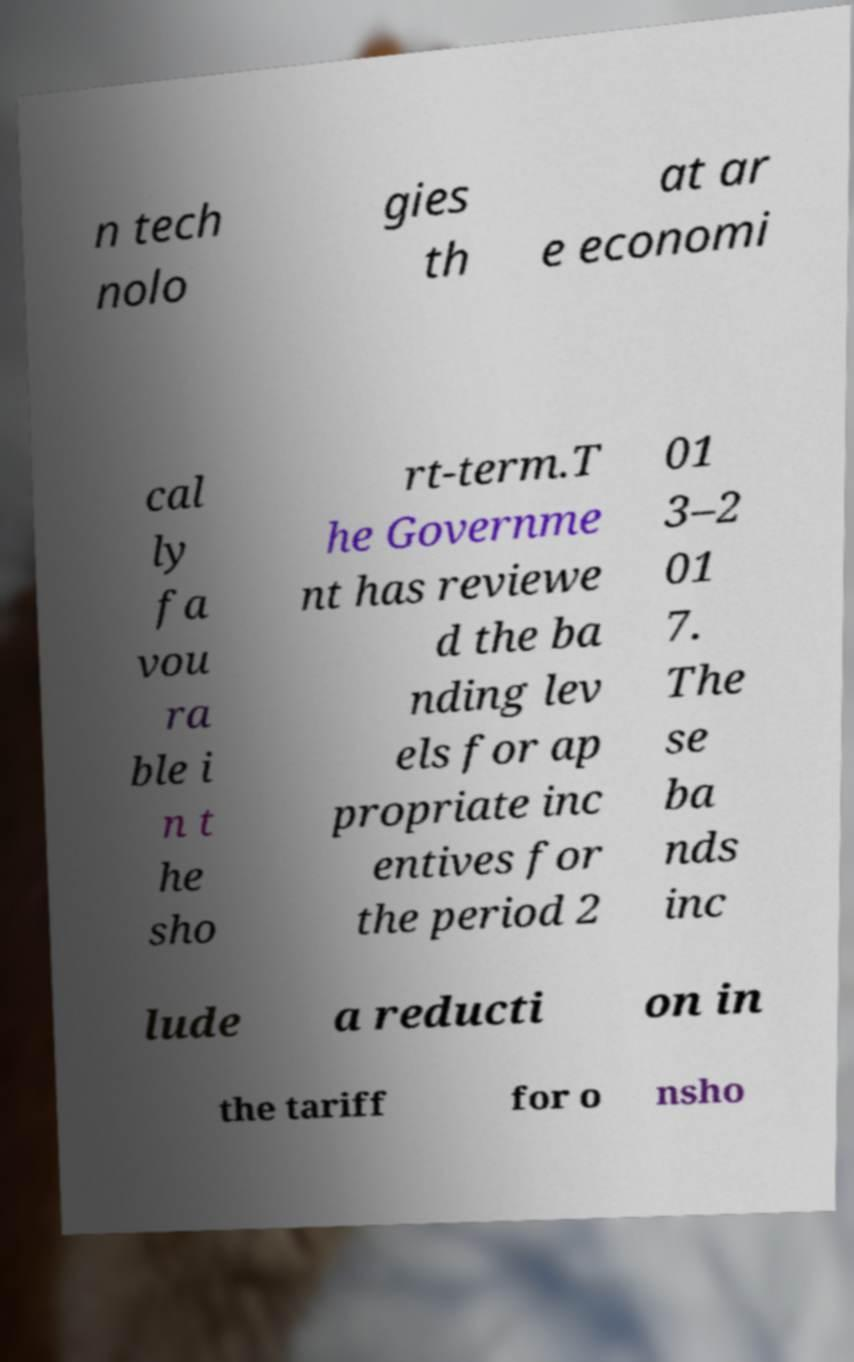Please read and relay the text visible in this image. What does it say? n tech nolo gies th at ar e economi cal ly fa vou ra ble i n t he sho rt-term.T he Governme nt has reviewe d the ba nding lev els for ap propriate inc entives for the period 2 01 3–2 01 7. The se ba nds inc lude a reducti on in the tariff for o nsho 